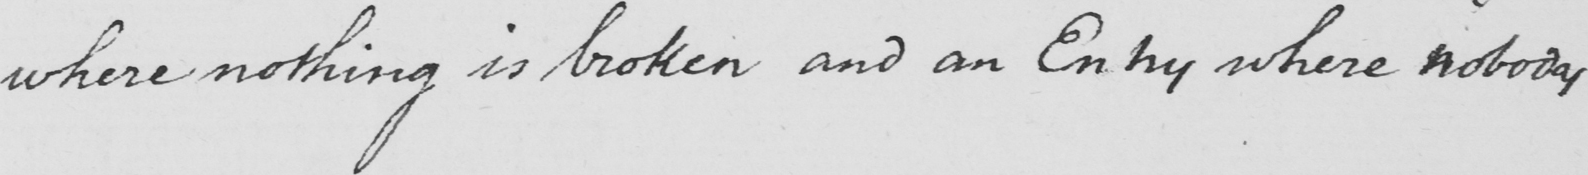Please provide the text content of this handwritten line. where nothing is broken and an Entry where nobody 